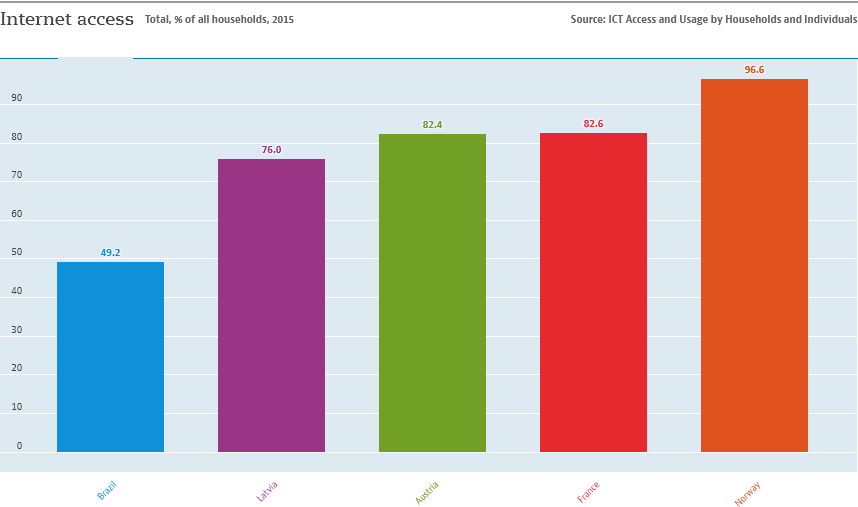Indicate a few pertinent items in this graphic. There are five colors displayed in the graph. The difference between the largest and second largest bar is 14. 